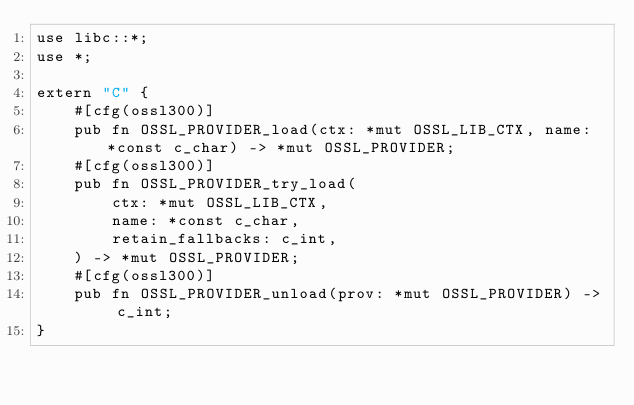Convert code to text. <code><loc_0><loc_0><loc_500><loc_500><_Rust_>use libc::*;
use *;

extern "C" {
    #[cfg(ossl300)]
    pub fn OSSL_PROVIDER_load(ctx: *mut OSSL_LIB_CTX, name: *const c_char) -> *mut OSSL_PROVIDER;
    #[cfg(ossl300)]
    pub fn OSSL_PROVIDER_try_load(
        ctx: *mut OSSL_LIB_CTX,
        name: *const c_char,
        retain_fallbacks: c_int,
    ) -> *mut OSSL_PROVIDER;
    #[cfg(ossl300)]
    pub fn OSSL_PROVIDER_unload(prov: *mut OSSL_PROVIDER) -> c_int;
}
</code> 